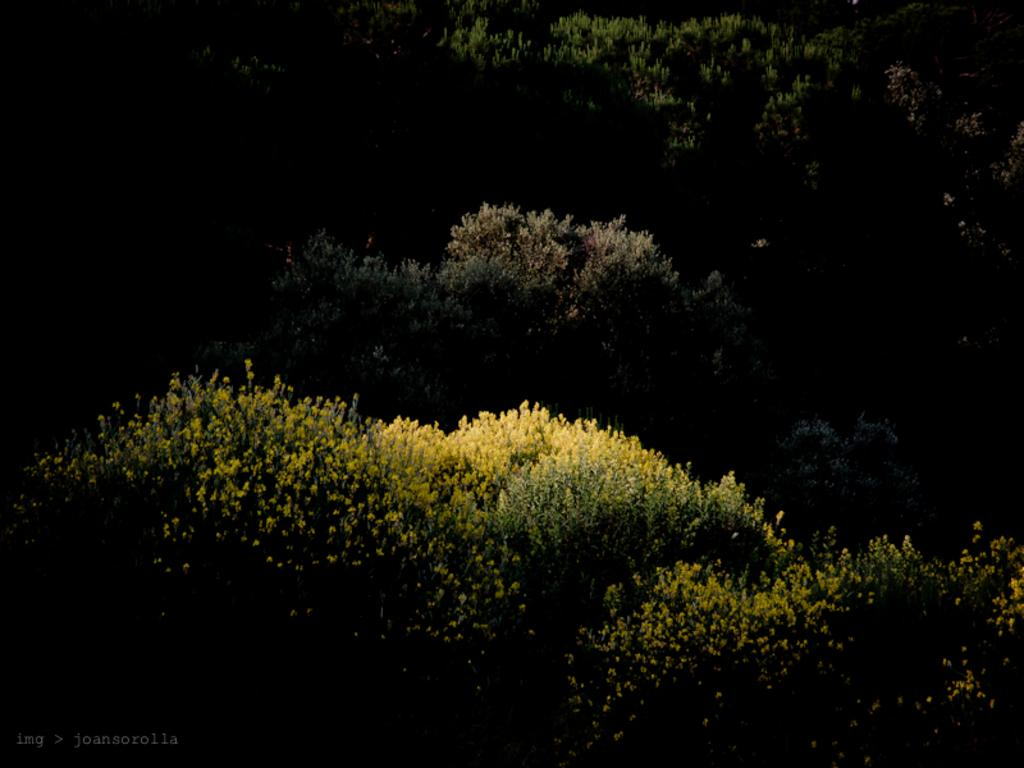What type of vegetation can be seen in the image? There are trees and plants in the image. Can you describe the specific types of plants in the image? Unfortunately, the specific types of plants cannot be determined from the image alone. What is the primary color of the trees in the image? The primary color of the trees in the image cannot be determined from the image alone. What type of scarf is draped over the tree in the image? There is no scarf present in the image; it features trees and plants only. Can you read the note that is attached to the plant in the image? There is no note present in the image; it features trees and plants only. 